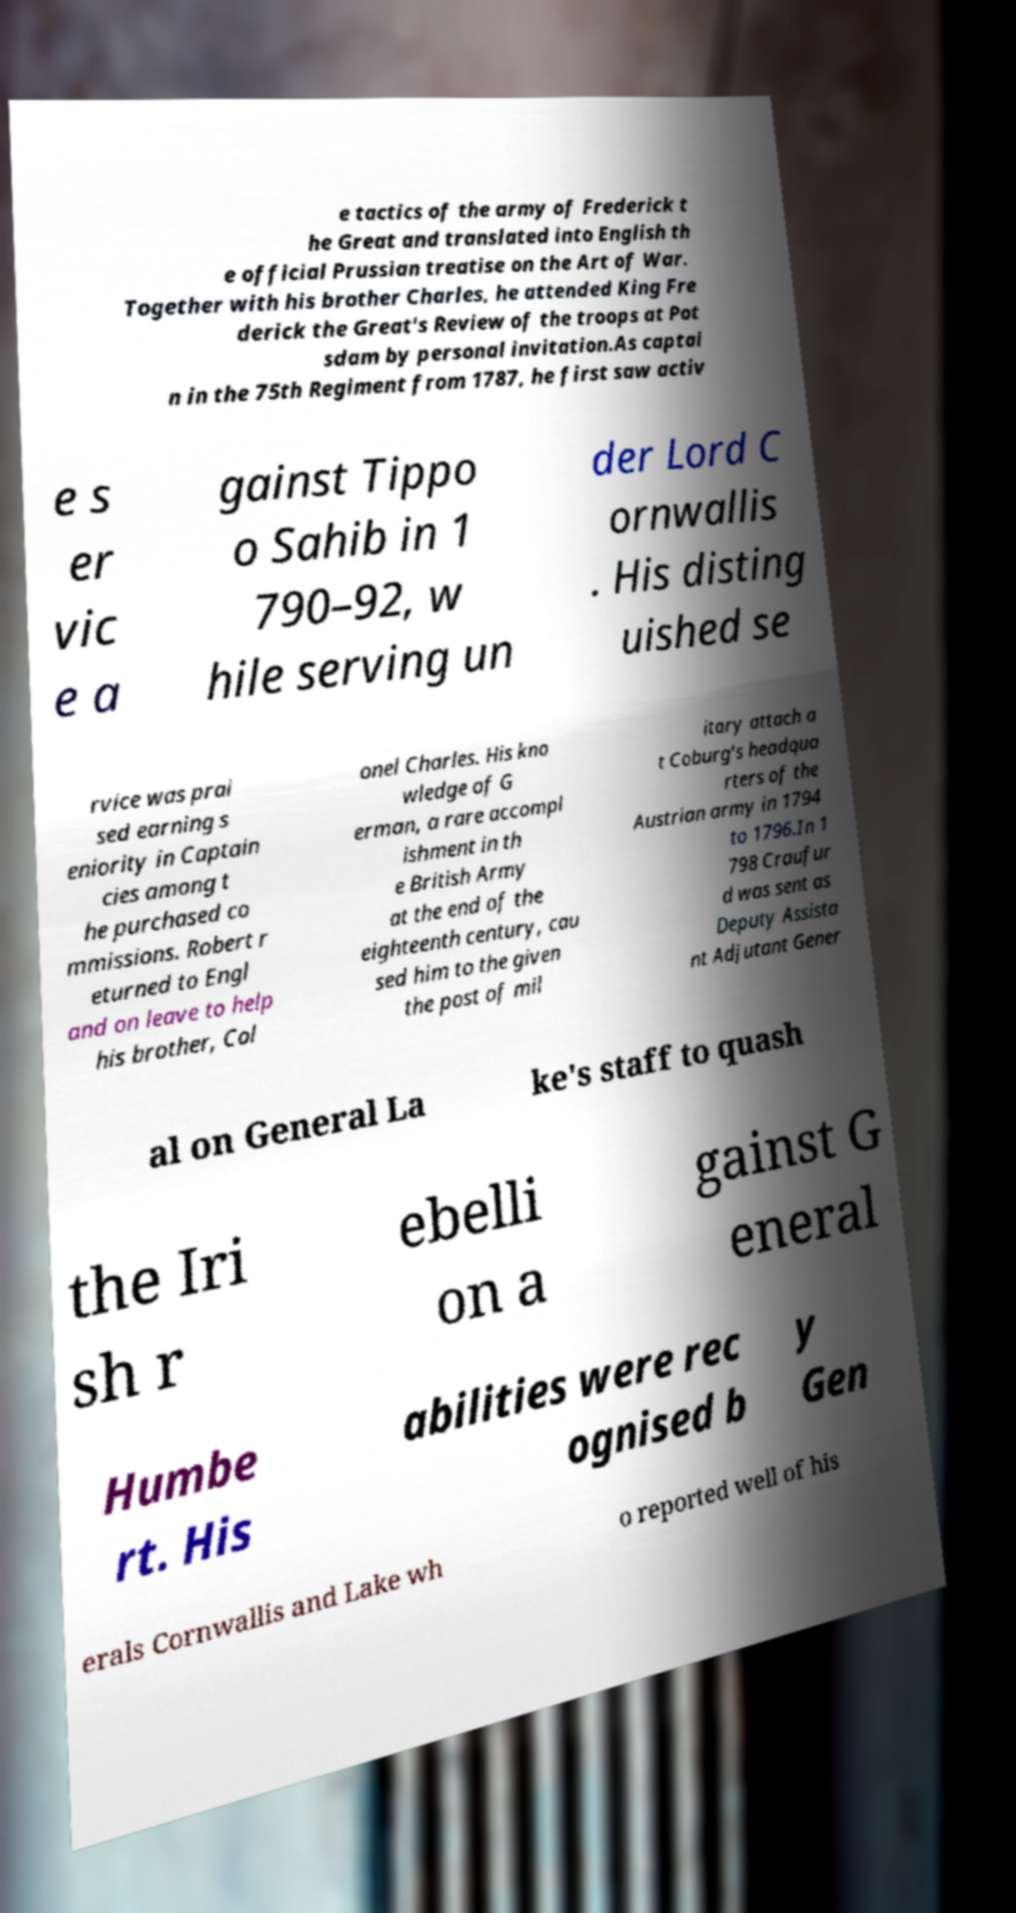There's text embedded in this image that I need extracted. Can you transcribe it verbatim? e tactics of the army of Frederick t he Great and translated into English th e official Prussian treatise on the Art of War. Together with his brother Charles, he attended King Fre derick the Great's Review of the troops at Pot sdam by personal invitation.As captai n in the 75th Regiment from 1787, he first saw activ e s er vic e a gainst Tippo o Sahib in 1 790–92, w hile serving un der Lord C ornwallis . His disting uished se rvice was prai sed earning s eniority in Captain cies among t he purchased co mmissions. Robert r eturned to Engl and on leave to help his brother, Col onel Charles. His kno wledge of G erman, a rare accompl ishment in th e British Army at the end of the eighteenth century, cau sed him to the given the post of mil itary attach a t Coburg’s headqua rters of the Austrian army in 1794 to 1796.In 1 798 Craufur d was sent as Deputy Assista nt Adjutant Gener al on General La ke's staff to quash the Iri sh r ebelli on a gainst G eneral Humbe rt. His abilities were rec ognised b y Gen erals Cornwallis and Lake wh o reported well of his 